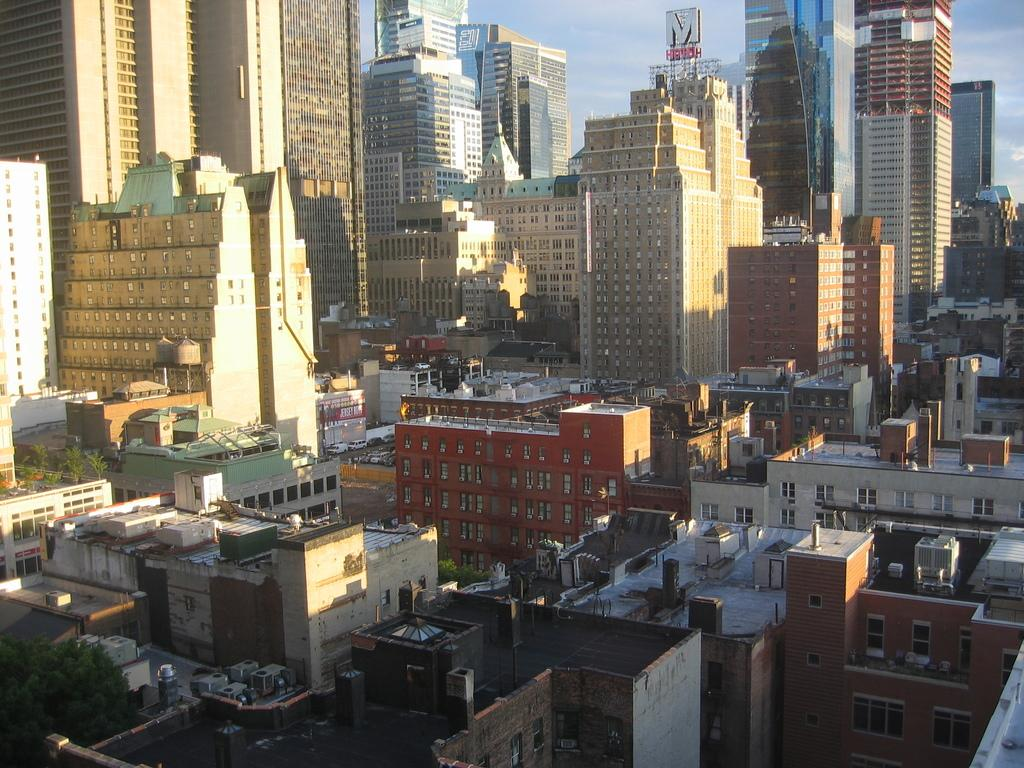What type of structures can be seen in the image? There are many buildings and towers in the image. Can you describe the vegetation present in the image? There is a tree on the left side of the image. How many potatoes are visible in the image? There are no potatoes present in the image. What type of vase can be seen in the image? There is no vase present in the image. 